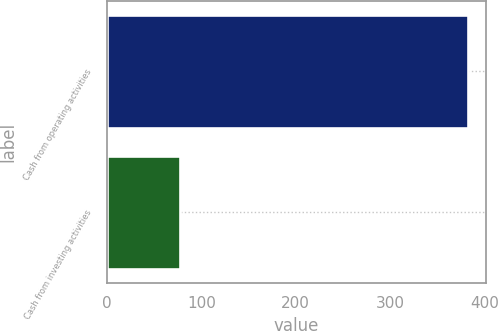Convert chart. <chart><loc_0><loc_0><loc_500><loc_500><bar_chart><fcel>Cash from operating activities<fcel>Cash from investing activities<nl><fcel>382<fcel>77<nl></chart> 